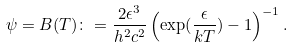Convert formula to latex. <formula><loc_0><loc_0><loc_500><loc_500>\psi = B ( T ) \colon = \frac { 2 \epsilon ^ { 3 } } { h ^ { 2 } c ^ { 2 } } \left ( \exp ( \frac { \epsilon } { k T } ) - 1 \right ) ^ { - 1 } .</formula> 